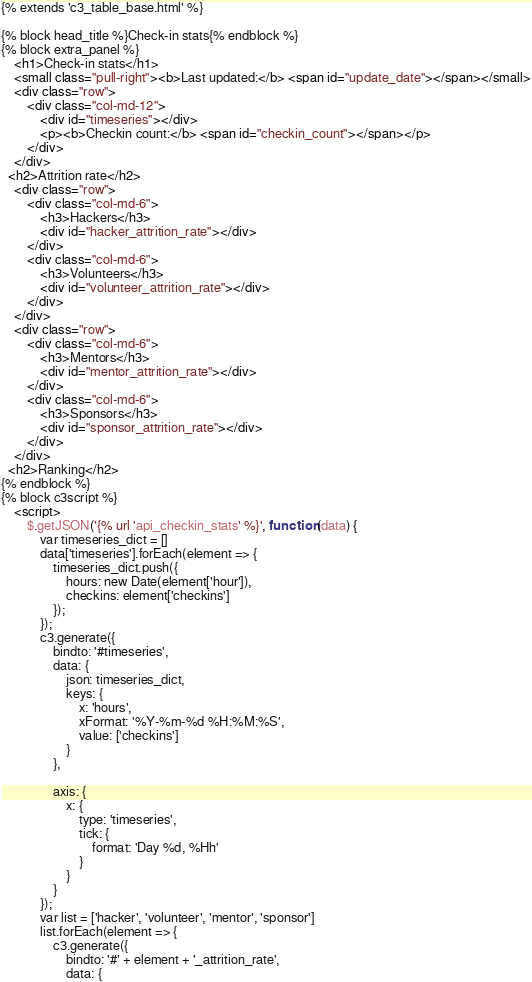Convert code to text. <code><loc_0><loc_0><loc_500><loc_500><_HTML_>{% extends 'c3_table_base.html' %}

{% block head_title %}Check-in stats{% endblock %}
{% block extra_panel %}
    <h1>Check-in stats</h1>
    <small class="pull-right"><b>Last updated:</b> <span id="update_date"></span></small>
    <div class="row">
        <div class="col-md-12">
            <div id="timeseries"></div>
            <p><b>Checkin count:</b> <span id="checkin_count"></span></p>
        </div>
    </div>
  <h2>Attrition rate</h2>
    <div class="row">
        <div class="col-md-6">
            <h3>Hackers</h3>
            <div id="hacker_attrition_rate"></div>
        </div>
        <div class="col-md-6">
            <h3>Volunteers</h3>
            <div id="volunteer_attrition_rate"></div>
        </div>
    </div>
    <div class="row">
        <div class="col-md-6">
            <h3>Mentors</h3>
            <div id="mentor_attrition_rate"></div>
        </div>
        <div class="col-md-6">
            <h3>Sponsors</h3>
            <div id="sponsor_attrition_rate"></div>
        </div>
    </div>
  <h2>Ranking</h2>
{% endblock %}
{% block c3script %}
    <script>
        $.getJSON('{% url 'api_checkin_stats' %}', function (data) {
            var timeseries_dict = []
            data['timeseries'].forEach(element => {
                timeseries_dict.push({
                    hours: new Date(element['hour']),
                    checkins: element['checkins']
                });
            });
            c3.generate({
                bindto: '#timeseries',
                data: {
                    json: timeseries_dict,
                    keys: {
                        x: 'hours',
                        xFormat: '%Y-%m-%d %H:%M:%S',
                        value: ['checkins']
                    }
                },

                axis: {
                    x: {
                        type: 'timeseries',
                        tick: {
                            format: 'Day %d, %Hh'
                        }
                    }
                }
            });
            var list = ['hacker', 'volunteer', 'mentor', 'sponsor']
            list.forEach(element => {
                c3.generate({
                    bindto: '#' + element + '_attrition_rate',
                    data: {</code> 